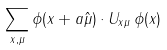Convert formula to latex. <formula><loc_0><loc_0><loc_500><loc_500>\sum _ { x , \mu } \phi ( x + a \hat { \mu } ) \cdot U _ { x \mu } \, \phi ( x )</formula> 